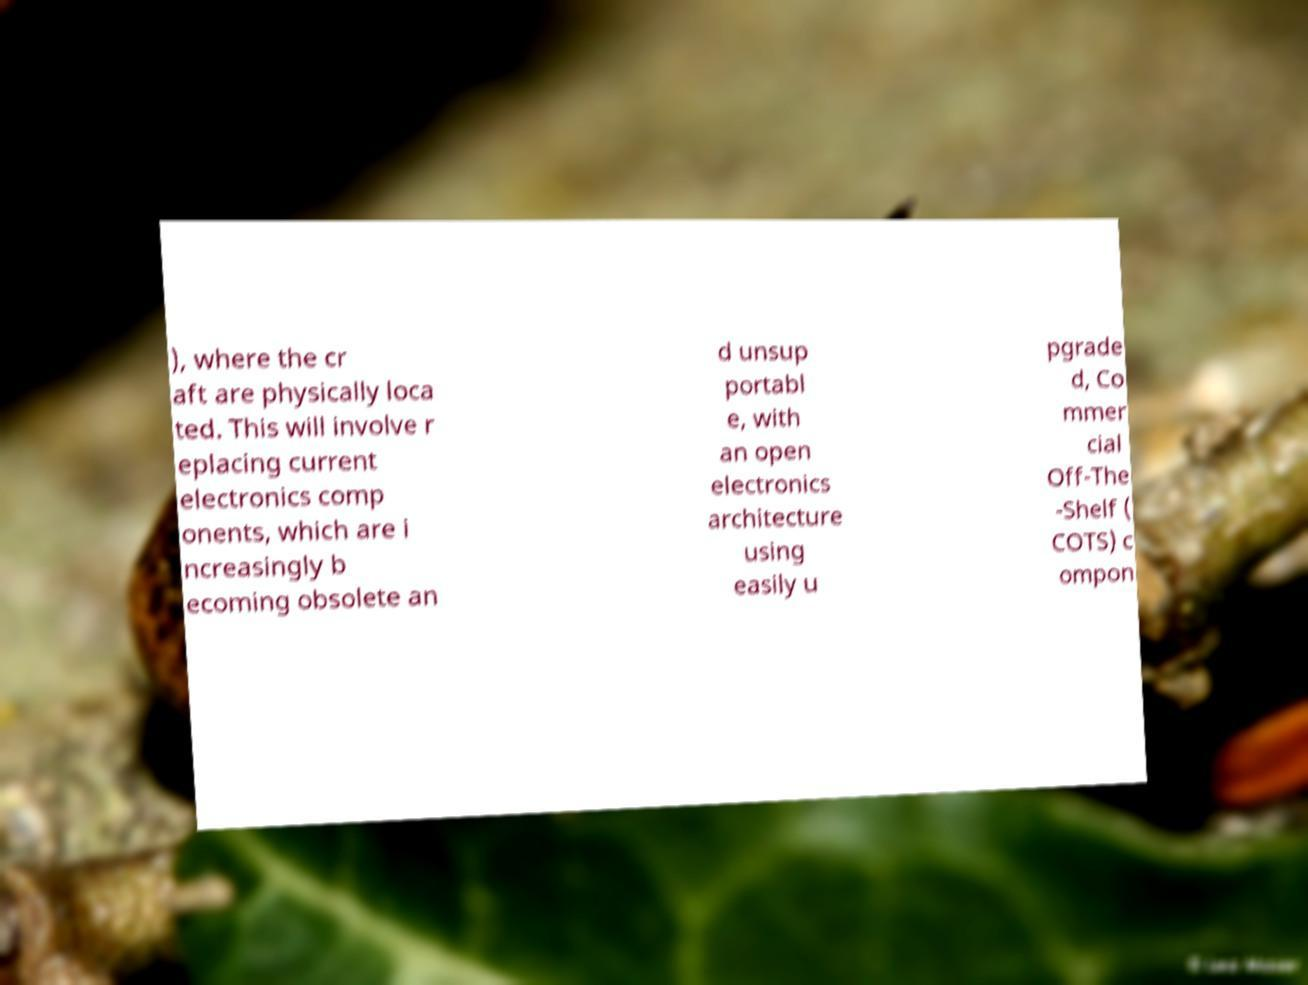There's text embedded in this image that I need extracted. Can you transcribe it verbatim? ), where the cr aft are physically loca ted. This will involve r eplacing current electronics comp onents, which are i ncreasingly b ecoming obsolete an d unsup portabl e, with an open electronics architecture using easily u pgrade d, Co mmer cial Off-The -Shelf ( COTS) c ompon 